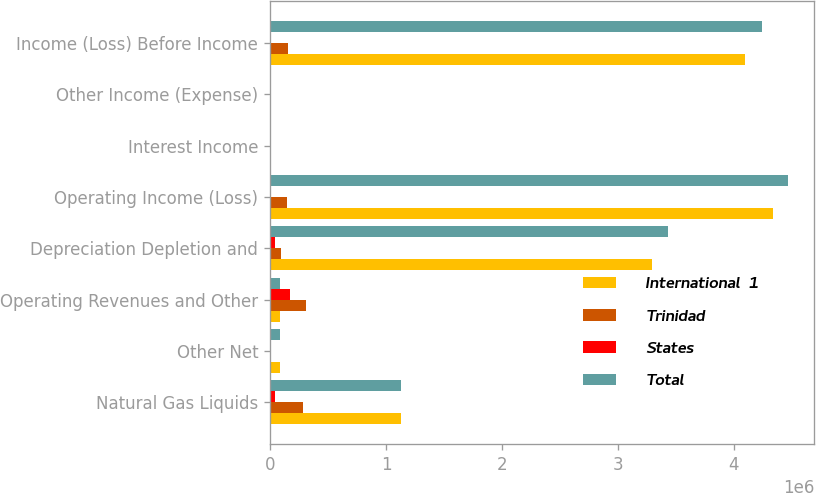<chart> <loc_0><loc_0><loc_500><loc_500><stacked_bar_chart><ecel><fcel>Natural Gas Liquids<fcel>Other Net<fcel>Operating Revenues and Other<fcel>Depreciation Depletion and<fcel>Operating Income (Loss)<fcel>Interest Income<fcel>Other Income (Expense)<fcel>Income (Loss) Before Income<nl><fcel>International  1<fcel>1.12751e+06<fcel>89708<fcel>89671.5<fcel>3.2965e+06<fcel>4.33436e+06<fcel>9326<fcel>9580<fcel>4.09992e+06<nl><fcel>Trinidad<fcel>285053<fcel>49<fcel>309860<fcel>91971<fcel>147240<fcel>1612<fcel>2436<fcel>151288<nl><fcel>States<fcel>45618<fcel>24<fcel>170948<fcel>46938<fcel>12258<fcel>608<fcel>6858<fcel>10208<nl><fcel>Total<fcel>1.12751e+06<fcel>89635<fcel>89671.5<fcel>3.43541e+06<fcel>4.46935e+06<fcel>11546<fcel>5158<fcel>4.241e+06<nl></chart> 